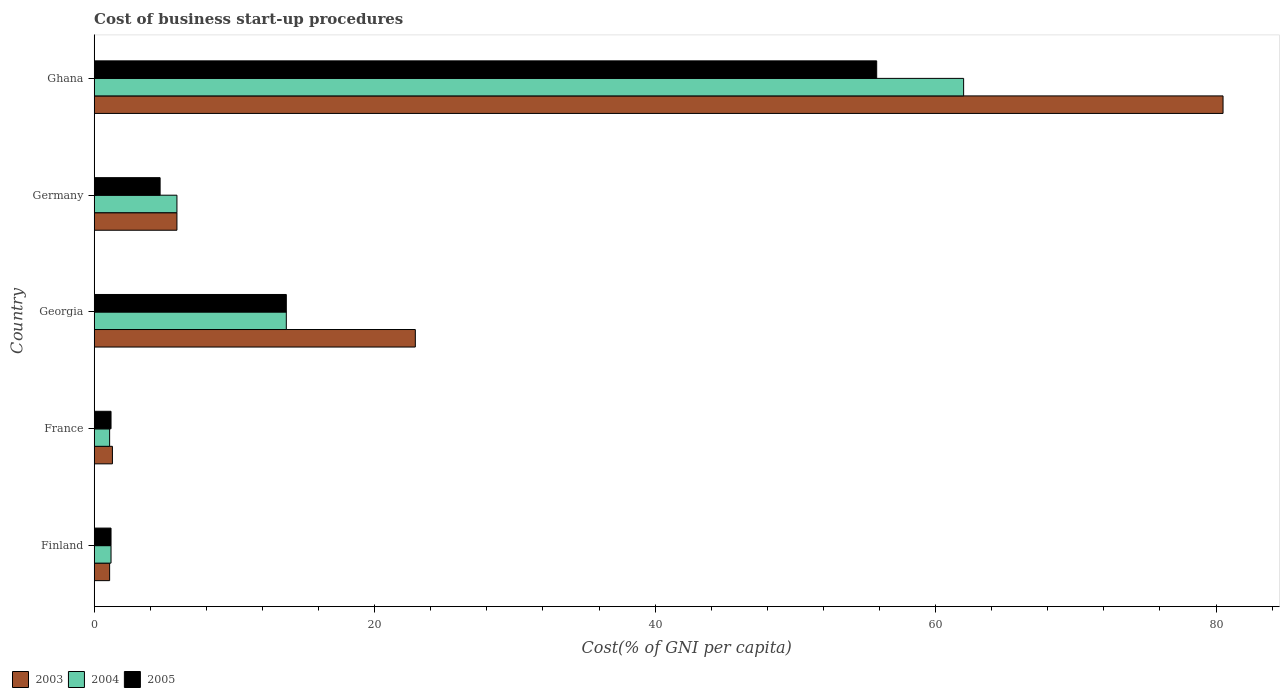Are the number of bars per tick equal to the number of legend labels?
Offer a terse response. Yes. Are the number of bars on each tick of the Y-axis equal?
Offer a very short reply. Yes. How many bars are there on the 4th tick from the top?
Provide a succinct answer. 3. How many bars are there on the 3rd tick from the bottom?
Offer a terse response. 3. In how many cases, is the number of bars for a given country not equal to the number of legend labels?
Offer a very short reply. 0. What is the cost of business start-up procedures in 2003 in Ghana?
Give a very brief answer. 80.5. What is the total cost of business start-up procedures in 2004 in the graph?
Provide a short and direct response. 83.9. What is the difference between the cost of business start-up procedures in 2003 in France and the cost of business start-up procedures in 2004 in Georgia?
Provide a short and direct response. -12.4. What is the average cost of business start-up procedures in 2005 per country?
Your answer should be very brief. 15.32. What is the difference between the cost of business start-up procedures in 2003 and cost of business start-up procedures in 2004 in Finland?
Your answer should be compact. -0.1. What is the ratio of the cost of business start-up procedures in 2004 in Germany to that in Ghana?
Make the answer very short. 0.1. Is the cost of business start-up procedures in 2004 in Georgia less than that in Ghana?
Ensure brevity in your answer.  Yes. What is the difference between the highest and the second highest cost of business start-up procedures in 2005?
Ensure brevity in your answer.  42.1. What is the difference between the highest and the lowest cost of business start-up procedures in 2003?
Make the answer very short. 79.4. In how many countries, is the cost of business start-up procedures in 2003 greater than the average cost of business start-up procedures in 2003 taken over all countries?
Your answer should be compact. 2. Is the sum of the cost of business start-up procedures in 2004 in France and Ghana greater than the maximum cost of business start-up procedures in 2005 across all countries?
Ensure brevity in your answer.  Yes. What does the 2nd bar from the bottom in Finland represents?
Ensure brevity in your answer.  2004. Are all the bars in the graph horizontal?
Your answer should be very brief. Yes. Are the values on the major ticks of X-axis written in scientific E-notation?
Make the answer very short. No. Does the graph contain grids?
Ensure brevity in your answer.  No. How many legend labels are there?
Make the answer very short. 3. What is the title of the graph?
Your answer should be compact. Cost of business start-up procedures. Does "1995" appear as one of the legend labels in the graph?
Give a very brief answer. No. What is the label or title of the X-axis?
Offer a very short reply. Cost(% of GNI per capita). What is the label or title of the Y-axis?
Provide a succinct answer. Country. What is the Cost(% of GNI per capita) in 2004 in Finland?
Keep it short and to the point. 1.2. What is the Cost(% of GNI per capita) of 2004 in France?
Your answer should be compact. 1.1. What is the Cost(% of GNI per capita) of 2005 in France?
Your answer should be very brief. 1.2. What is the Cost(% of GNI per capita) in 2003 in Georgia?
Provide a short and direct response. 22.9. What is the Cost(% of GNI per capita) in 2004 in Georgia?
Offer a very short reply. 13.7. What is the Cost(% of GNI per capita) of 2005 in Georgia?
Your answer should be very brief. 13.7. What is the Cost(% of GNI per capita) in 2003 in Germany?
Provide a succinct answer. 5.9. What is the Cost(% of GNI per capita) in 2003 in Ghana?
Ensure brevity in your answer.  80.5. What is the Cost(% of GNI per capita) of 2005 in Ghana?
Make the answer very short. 55.8. Across all countries, what is the maximum Cost(% of GNI per capita) in 2003?
Your answer should be compact. 80.5. Across all countries, what is the maximum Cost(% of GNI per capita) of 2004?
Provide a short and direct response. 62. Across all countries, what is the maximum Cost(% of GNI per capita) in 2005?
Provide a short and direct response. 55.8. Across all countries, what is the minimum Cost(% of GNI per capita) in 2004?
Keep it short and to the point. 1.1. What is the total Cost(% of GNI per capita) of 2003 in the graph?
Your answer should be compact. 111.7. What is the total Cost(% of GNI per capita) in 2004 in the graph?
Make the answer very short. 83.9. What is the total Cost(% of GNI per capita) in 2005 in the graph?
Your answer should be compact. 76.6. What is the difference between the Cost(% of GNI per capita) in 2003 in Finland and that in France?
Provide a succinct answer. -0.2. What is the difference between the Cost(% of GNI per capita) in 2004 in Finland and that in France?
Offer a very short reply. 0.1. What is the difference between the Cost(% of GNI per capita) of 2003 in Finland and that in Georgia?
Your answer should be compact. -21.8. What is the difference between the Cost(% of GNI per capita) in 2005 in Finland and that in Georgia?
Give a very brief answer. -12.5. What is the difference between the Cost(% of GNI per capita) of 2003 in Finland and that in Germany?
Offer a very short reply. -4.8. What is the difference between the Cost(% of GNI per capita) of 2004 in Finland and that in Germany?
Offer a terse response. -4.7. What is the difference between the Cost(% of GNI per capita) in 2003 in Finland and that in Ghana?
Give a very brief answer. -79.4. What is the difference between the Cost(% of GNI per capita) in 2004 in Finland and that in Ghana?
Ensure brevity in your answer.  -60.8. What is the difference between the Cost(% of GNI per capita) in 2005 in Finland and that in Ghana?
Your answer should be compact. -54.6. What is the difference between the Cost(% of GNI per capita) of 2003 in France and that in Georgia?
Ensure brevity in your answer.  -21.6. What is the difference between the Cost(% of GNI per capita) of 2005 in France and that in Georgia?
Provide a short and direct response. -12.5. What is the difference between the Cost(% of GNI per capita) of 2003 in France and that in Germany?
Ensure brevity in your answer.  -4.6. What is the difference between the Cost(% of GNI per capita) in 2004 in France and that in Germany?
Ensure brevity in your answer.  -4.8. What is the difference between the Cost(% of GNI per capita) in 2005 in France and that in Germany?
Give a very brief answer. -3.5. What is the difference between the Cost(% of GNI per capita) of 2003 in France and that in Ghana?
Offer a terse response. -79.2. What is the difference between the Cost(% of GNI per capita) in 2004 in France and that in Ghana?
Ensure brevity in your answer.  -60.9. What is the difference between the Cost(% of GNI per capita) in 2005 in France and that in Ghana?
Offer a very short reply. -54.6. What is the difference between the Cost(% of GNI per capita) of 2003 in Georgia and that in Germany?
Your answer should be compact. 17. What is the difference between the Cost(% of GNI per capita) in 2004 in Georgia and that in Germany?
Provide a short and direct response. 7.8. What is the difference between the Cost(% of GNI per capita) of 2005 in Georgia and that in Germany?
Your answer should be very brief. 9. What is the difference between the Cost(% of GNI per capita) in 2003 in Georgia and that in Ghana?
Offer a very short reply. -57.6. What is the difference between the Cost(% of GNI per capita) of 2004 in Georgia and that in Ghana?
Make the answer very short. -48.3. What is the difference between the Cost(% of GNI per capita) in 2005 in Georgia and that in Ghana?
Your answer should be compact. -42.1. What is the difference between the Cost(% of GNI per capita) of 2003 in Germany and that in Ghana?
Keep it short and to the point. -74.6. What is the difference between the Cost(% of GNI per capita) in 2004 in Germany and that in Ghana?
Offer a terse response. -56.1. What is the difference between the Cost(% of GNI per capita) in 2005 in Germany and that in Ghana?
Provide a succinct answer. -51.1. What is the difference between the Cost(% of GNI per capita) of 2003 in Finland and the Cost(% of GNI per capita) of 2004 in France?
Give a very brief answer. 0. What is the difference between the Cost(% of GNI per capita) in 2003 in Finland and the Cost(% of GNI per capita) in 2005 in France?
Ensure brevity in your answer.  -0.1. What is the difference between the Cost(% of GNI per capita) in 2004 in Finland and the Cost(% of GNI per capita) in 2005 in France?
Offer a very short reply. 0. What is the difference between the Cost(% of GNI per capita) in 2003 in Finland and the Cost(% of GNI per capita) in 2004 in Georgia?
Provide a short and direct response. -12.6. What is the difference between the Cost(% of GNI per capita) in 2003 in Finland and the Cost(% of GNI per capita) in 2005 in Georgia?
Provide a short and direct response. -12.6. What is the difference between the Cost(% of GNI per capita) of 2003 in Finland and the Cost(% of GNI per capita) of 2005 in Germany?
Provide a succinct answer. -3.6. What is the difference between the Cost(% of GNI per capita) of 2004 in Finland and the Cost(% of GNI per capita) of 2005 in Germany?
Give a very brief answer. -3.5. What is the difference between the Cost(% of GNI per capita) of 2003 in Finland and the Cost(% of GNI per capita) of 2004 in Ghana?
Keep it short and to the point. -60.9. What is the difference between the Cost(% of GNI per capita) in 2003 in Finland and the Cost(% of GNI per capita) in 2005 in Ghana?
Make the answer very short. -54.7. What is the difference between the Cost(% of GNI per capita) in 2004 in Finland and the Cost(% of GNI per capita) in 2005 in Ghana?
Your answer should be very brief. -54.6. What is the difference between the Cost(% of GNI per capita) of 2003 in France and the Cost(% of GNI per capita) of 2005 in Georgia?
Your response must be concise. -12.4. What is the difference between the Cost(% of GNI per capita) of 2003 in France and the Cost(% of GNI per capita) of 2004 in Ghana?
Your answer should be compact. -60.7. What is the difference between the Cost(% of GNI per capita) of 2003 in France and the Cost(% of GNI per capita) of 2005 in Ghana?
Provide a short and direct response. -54.5. What is the difference between the Cost(% of GNI per capita) in 2004 in France and the Cost(% of GNI per capita) in 2005 in Ghana?
Offer a terse response. -54.7. What is the difference between the Cost(% of GNI per capita) in 2003 in Georgia and the Cost(% of GNI per capita) in 2004 in Germany?
Offer a terse response. 17. What is the difference between the Cost(% of GNI per capita) in 2004 in Georgia and the Cost(% of GNI per capita) in 2005 in Germany?
Your answer should be very brief. 9. What is the difference between the Cost(% of GNI per capita) of 2003 in Georgia and the Cost(% of GNI per capita) of 2004 in Ghana?
Your answer should be compact. -39.1. What is the difference between the Cost(% of GNI per capita) in 2003 in Georgia and the Cost(% of GNI per capita) in 2005 in Ghana?
Make the answer very short. -32.9. What is the difference between the Cost(% of GNI per capita) of 2004 in Georgia and the Cost(% of GNI per capita) of 2005 in Ghana?
Ensure brevity in your answer.  -42.1. What is the difference between the Cost(% of GNI per capita) in 2003 in Germany and the Cost(% of GNI per capita) in 2004 in Ghana?
Provide a succinct answer. -56.1. What is the difference between the Cost(% of GNI per capita) in 2003 in Germany and the Cost(% of GNI per capita) in 2005 in Ghana?
Keep it short and to the point. -49.9. What is the difference between the Cost(% of GNI per capita) in 2004 in Germany and the Cost(% of GNI per capita) in 2005 in Ghana?
Your response must be concise. -49.9. What is the average Cost(% of GNI per capita) of 2003 per country?
Your answer should be very brief. 22.34. What is the average Cost(% of GNI per capita) of 2004 per country?
Provide a succinct answer. 16.78. What is the average Cost(% of GNI per capita) of 2005 per country?
Your answer should be very brief. 15.32. What is the difference between the Cost(% of GNI per capita) of 2003 and Cost(% of GNI per capita) of 2004 in Finland?
Keep it short and to the point. -0.1. What is the difference between the Cost(% of GNI per capita) of 2003 and Cost(% of GNI per capita) of 2005 in France?
Keep it short and to the point. 0.1. What is the difference between the Cost(% of GNI per capita) of 2004 and Cost(% of GNI per capita) of 2005 in France?
Ensure brevity in your answer.  -0.1. What is the difference between the Cost(% of GNI per capita) in 2003 and Cost(% of GNI per capita) in 2004 in Georgia?
Ensure brevity in your answer.  9.2. What is the difference between the Cost(% of GNI per capita) in 2003 and Cost(% of GNI per capita) in 2004 in Germany?
Your response must be concise. 0. What is the difference between the Cost(% of GNI per capita) in 2003 and Cost(% of GNI per capita) in 2005 in Germany?
Your response must be concise. 1.2. What is the difference between the Cost(% of GNI per capita) of 2003 and Cost(% of GNI per capita) of 2004 in Ghana?
Offer a terse response. 18.5. What is the difference between the Cost(% of GNI per capita) in 2003 and Cost(% of GNI per capita) in 2005 in Ghana?
Ensure brevity in your answer.  24.7. What is the difference between the Cost(% of GNI per capita) of 2004 and Cost(% of GNI per capita) of 2005 in Ghana?
Your answer should be compact. 6.2. What is the ratio of the Cost(% of GNI per capita) in 2003 in Finland to that in France?
Keep it short and to the point. 0.85. What is the ratio of the Cost(% of GNI per capita) in 2003 in Finland to that in Georgia?
Ensure brevity in your answer.  0.05. What is the ratio of the Cost(% of GNI per capita) of 2004 in Finland to that in Georgia?
Ensure brevity in your answer.  0.09. What is the ratio of the Cost(% of GNI per capita) in 2005 in Finland to that in Georgia?
Provide a short and direct response. 0.09. What is the ratio of the Cost(% of GNI per capita) in 2003 in Finland to that in Germany?
Your answer should be compact. 0.19. What is the ratio of the Cost(% of GNI per capita) in 2004 in Finland to that in Germany?
Your answer should be very brief. 0.2. What is the ratio of the Cost(% of GNI per capita) of 2005 in Finland to that in Germany?
Your answer should be compact. 0.26. What is the ratio of the Cost(% of GNI per capita) in 2003 in Finland to that in Ghana?
Offer a terse response. 0.01. What is the ratio of the Cost(% of GNI per capita) of 2004 in Finland to that in Ghana?
Ensure brevity in your answer.  0.02. What is the ratio of the Cost(% of GNI per capita) of 2005 in Finland to that in Ghana?
Your answer should be very brief. 0.02. What is the ratio of the Cost(% of GNI per capita) of 2003 in France to that in Georgia?
Offer a terse response. 0.06. What is the ratio of the Cost(% of GNI per capita) of 2004 in France to that in Georgia?
Provide a short and direct response. 0.08. What is the ratio of the Cost(% of GNI per capita) of 2005 in France to that in Georgia?
Provide a short and direct response. 0.09. What is the ratio of the Cost(% of GNI per capita) of 2003 in France to that in Germany?
Keep it short and to the point. 0.22. What is the ratio of the Cost(% of GNI per capita) of 2004 in France to that in Germany?
Your response must be concise. 0.19. What is the ratio of the Cost(% of GNI per capita) in 2005 in France to that in Germany?
Provide a succinct answer. 0.26. What is the ratio of the Cost(% of GNI per capita) of 2003 in France to that in Ghana?
Offer a very short reply. 0.02. What is the ratio of the Cost(% of GNI per capita) in 2004 in France to that in Ghana?
Ensure brevity in your answer.  0.02. What is the ratio of the Cost(% of GNI per capita) of 2005 in France to that in Ghana?
Your answer should be very brief. 0.02. What is the ratio of the Cost(% of GNI per capita) of 2003 in Georgia to that in Germany?
Make the answer very short. 3.88. What is the ratio of the Cost(% of GNI per capita) in 2004 in Georgia to that in Germany?
Offer a very short reply. 2.32. What is the ratio of the Cost(% of GNI per capita) of 2005 in Georgia to that in Germany?
Provide a succinct answer. 2.91. What is the ratio of the Cost(% of GNI per capita) of 2003 in Georgia to that in Ghana?
Ensure brevity in your answer.  0.28. What is the ratio of the Cost(% of GNI per capita) in 2004 in Georgia to that in Ghana?
Provide a succinct answer. 0.22. What is the ratio of the Cost(% of GNI per capita) in 2005 in Georgia to that in Ghana?
Offer a very short reply. 0.25. What is the ratio of the Cost(% of GNI per capita) in 2003 in Germany to that in Ghana?
Make the answer very short. 0.07. What is the ratio of the Cost(% of GNI per capita) in 2004 in Germany to that in Ghana?
Your answer should be compact. 0.1. What is the ratio of the Cost(% of GNI per capita) of 2005 in Germany to that in Ghana?
Provide a succinct answer. 0.08. What is the difference between the highest and the second highest Cost(% of GNI per capita) of 2003?
Offer a very short reply. 57.6. What is the difference between the highest and the second highest Cost(% of GNI per capita) in 2004?
Make the answer very short. 48.3. What is the difference between the highest and the second highest Cost(% of GNI per capita) of 2005?
Keep it short and to the point. 42.1. What is the difference between the highest and the lowest Cost(% of GNI per capita) in 2003?
Offer a terse response. 79.4. What is the difference between the highest and the lowest Cost(% of GNI per capita) in 2004?
Provide a short and direct response. 60.9. What is the difference between the highest and the lowest Cost(% of GNI per capita) in 2005?
Your response must be concise. 54.6. 